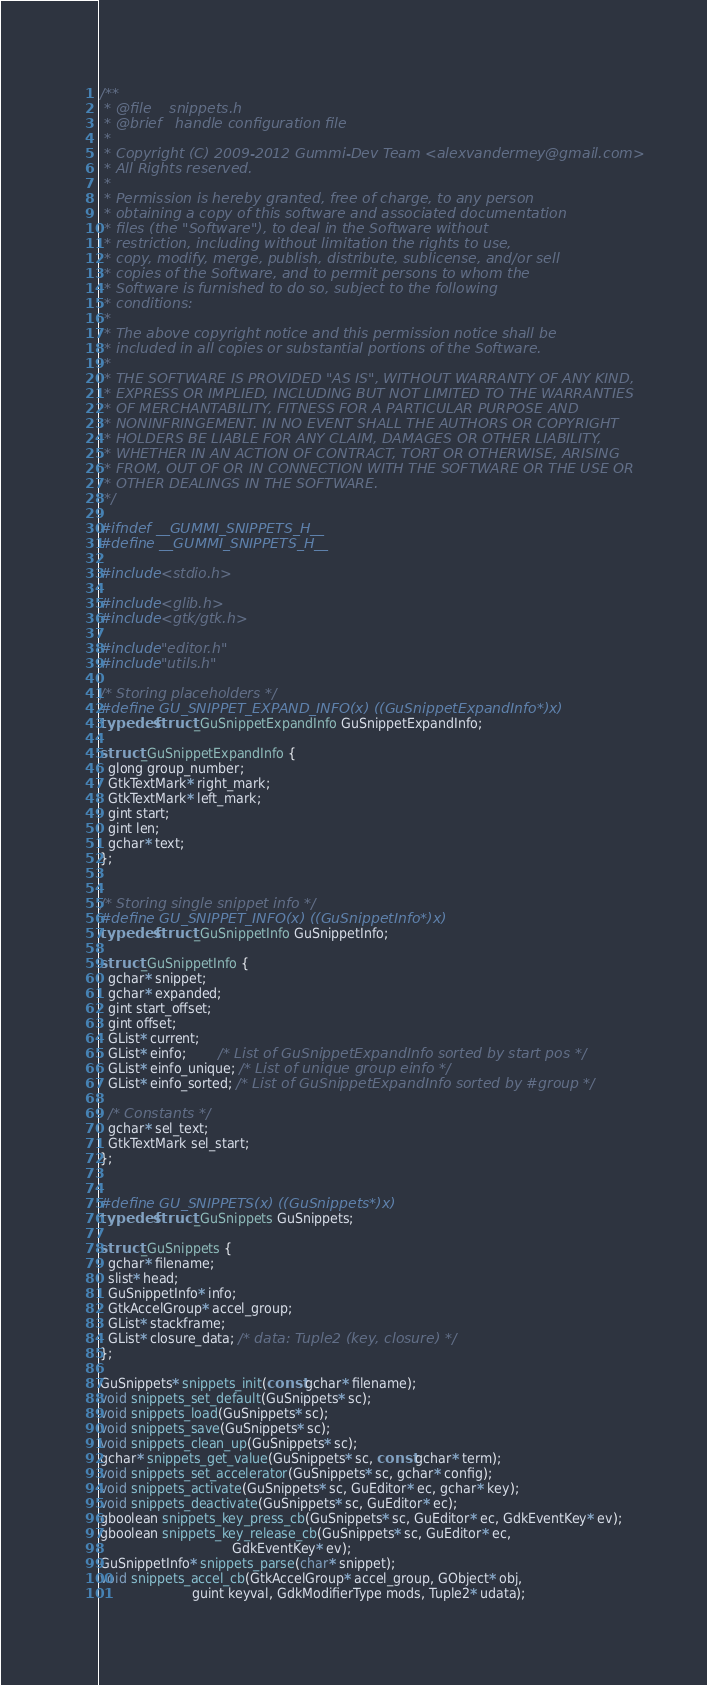<code> <loc_0><loc_0><loc_500><loc_500><_C_>/**
 * @file    snippets.h
 * @brief   handle configuration file
 *
 * Copyright (C) 2009-2012 Gummi-Dev Team <alexvandermey@gmail.com>
 * All Rights reserved.
 *
 * Permission is hereby granted, free of charge, to any person
 * obtaining a copy of this software and associated documentation
 * files (the "Software"), to deal in the Software without
 * restriction, including without limitation the rights to use,
 * copy, modify, merge, publish, distribute, sublicense, and/or sell
 * copies of the Software, and to permit persons to whom the
 * Software is furnished to do so, subject to the following
 * conditions:
 *
 * The above copyright notice and this permission notice shall be
 * included in all copies or substantial portions of the Software.
 *
 * THE SOFTWARE IS PROVIDED "AS IS", WITHOUT WARRANTY OF ANY KIND,
 * EXPRESS OR IMPLIED, INCLUDING BUT NOT LIMITED TO THE WARRANTIES
 * OF MERCHANTABILITY, FITNESS FOR A PARTICULAR PURPOSE AND
 * NONINFRINGEMENT. IN NO EVENT SHALL THE AUTHORS OR COPYRIGHT
 * HOLDERS BE LIABLE FOR ANY CLAIM, DAMAGES OR OTHER LIABILITY,
 * WHETHER IN AN ACTION OF CONTRACT, TORT OR OTHERWISE, ARISING
 * FROM, OUT OF OR IN CONNECTION WITH THE SOFTWARE OR THE USE OR
 * OTHER DEALINGS IN THE SOFTWARE.
 */

#ifndef __GUMMI_SNIPPETS_H__
#define __GUMMI_SNIPPETS_H__

#include <stdio.h>

#include <glib.h>
#include <gtk/gtk.h>

#include "editor.h"
#include "utils.h"

/* Storing placeholders */
#define GU_SNIPPET_EXPAND_INFO(x) ((GuSnippetExpandInfo*)x)
typedef struct _GuSnippetExpandInfo GuSnippetExpandInfo;

struct _GuSnippetExpandInfo {
  glong group_number;
  GtkTextMark* right_mark;
  GtkTextMark* left_mark;
  gint start;
  gint len;
  gchar* text;
};


/* Storing single snippet info */
#define GU_SNIPPET_INFO(x) ((GuSnippetInfo*)x)
typedef struct _GuSnippetInfo GuSnippetInfo;

struct _GuSnippetInfo {
  gchar* snippet;
  gchar* expanded;
  gint start_offset;
  gint offset;
  GList* current;
  GList* einfo;        /* List of GuSnippetExpandInfo sorted by start pos */
  GList* einfo_unique; /* List of unique group einfo */
  GList* einfo_sorted; /* List of GuSnippetExpandInfo sorted by #group */

  /* Constants */
  gchar* sel_text;
  GtkTextMark sel_start;
};


#define GU_SNIPPETS(x) ((GuSnippets*)x)
typedef struct _GuSnippets GuSnippets;

struct _GuSnippets {
  gchar* filename;
  slist* head;
  GuSnippetInfo* info;
  GtkAccelGroup* accel_group;
  GList* stackframe;
  GList* closure_data; /* data: Tuple2 (key, closure) */
};

GuSnippets* snippets_init(const gchar* filename);
void snippets_set_default(GuSnippets* sc);
void snippets_load(GuSnippets* sc);
void snippets_save(GuSnippets* sc);
void snippets_clean_up(GuSnippets* sc);
gchar* snippets_get_value(GuSnippets* sc, const gchar* term);
void snippets_set_accelerator(GuSnippets* sc, gchar* config);
void snippets_activate(GuSnippets* sc, GuEditor* ec, gchar* key);
void snippets_deactivate(GuSnippets* sc, GuEditor* ec);
gboolean snippets_key_press_cb(GuSnippets* sc, GuEditor* ec, GdkEventKey* ev);
gboolean snippets_key_release_cb(GuSnippets* sc, GuEditor* ec,
                                 GdkEventKey* ev);
GuSnippetInfo* snippets_parse(char* snippet);
void snippets_accel_cb(GtkAccelGroup* accel_group, GObject* obj,
                       guint keyval, GdkModifierType mods, Tuple2* udata);</code> 